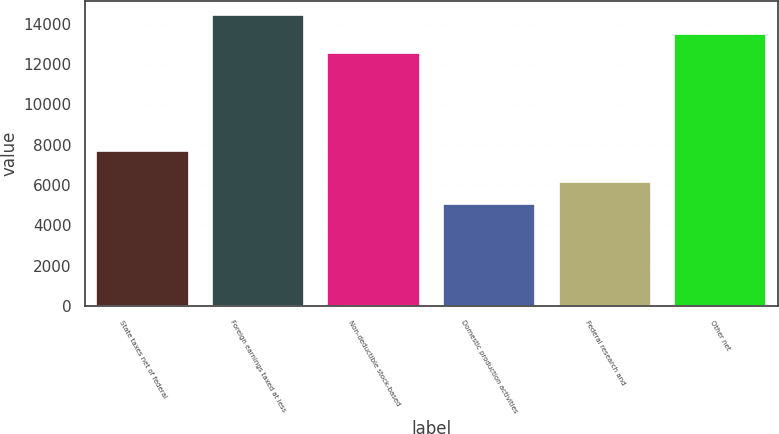Convert chart to OTSL. <chart><loc_0><loc_0><loc_500><loc_500><bar_chart><fcel>State taxes net of federal<fcel>Foreign earnings taxed at less<fcel>Non-deductible stock-based<fcel>Domestic production activities<fcel>Federal research and<fcel>Other net<nl><fcel>7690<fcel>14422.8<fcel>12570<fcel>5040<fcel>6156<fcel>13496.4<nl></chart> 